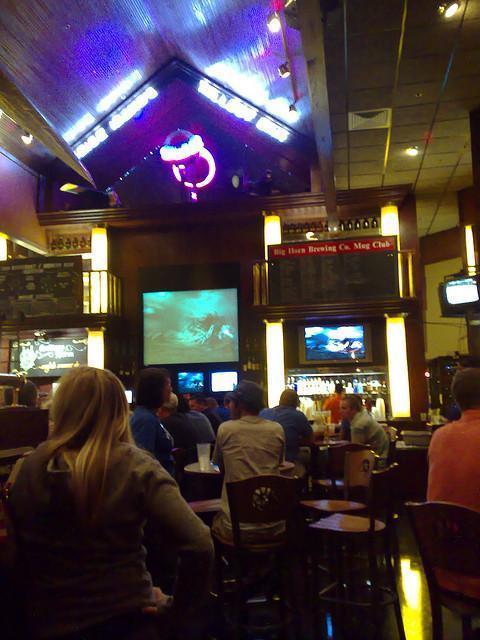How many people are in the photo?
Give a very brief answer. 4. How many chairs can be seen?
Give a very brief answer. 3. How many tvs are in the picture?
Give a very brief answer. 2. How many birds on the wire?
Give a very brief answer. 0. 